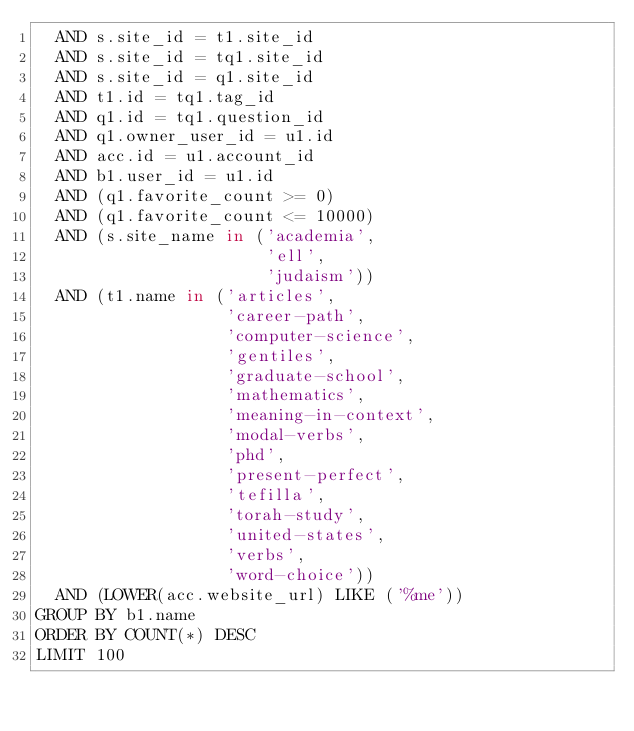Convert code to text. <code><loc_0><loc_0><loc_500><loc_500><_SQL_>  AND s.site_id = t1.site_id
  AND s.site_id = tq1.site_id
  AND s.site_id = q1.site_id
  AND t1.id = tq1.tag_id
  AND q1.id = tq1.question_id
  AND q1.owner_user_id = u1.id
  AND acc.id = u1.account_id
  AND b1.user_id = u1.id
  AND (q1.favorite_count >= 0)
  AND (q1.favorite_count <= 10000)
  AND (s.site_name in ('academia',
                       'ell',
                       'judaism'))
  AND (t1.name in ('articles',
                   'career-path',
                   'computer-science',
                   'gentiles',
                   'graduate-school',
                   'mathematics',
                   'meaning-in-context',
                   'modal-verbs',
                   'phd',
                   'present-perfect',
                   'tefilla',
                   'torah-study',
                   'united-states',
                   'verbs',
                   'word-choice'))
  AND (LOWER(acc.website_url) LIKE ('%me'))
GROUP BY b1.name
ORDER BY COUNT(*) DESC
LIMIT 100</code> 